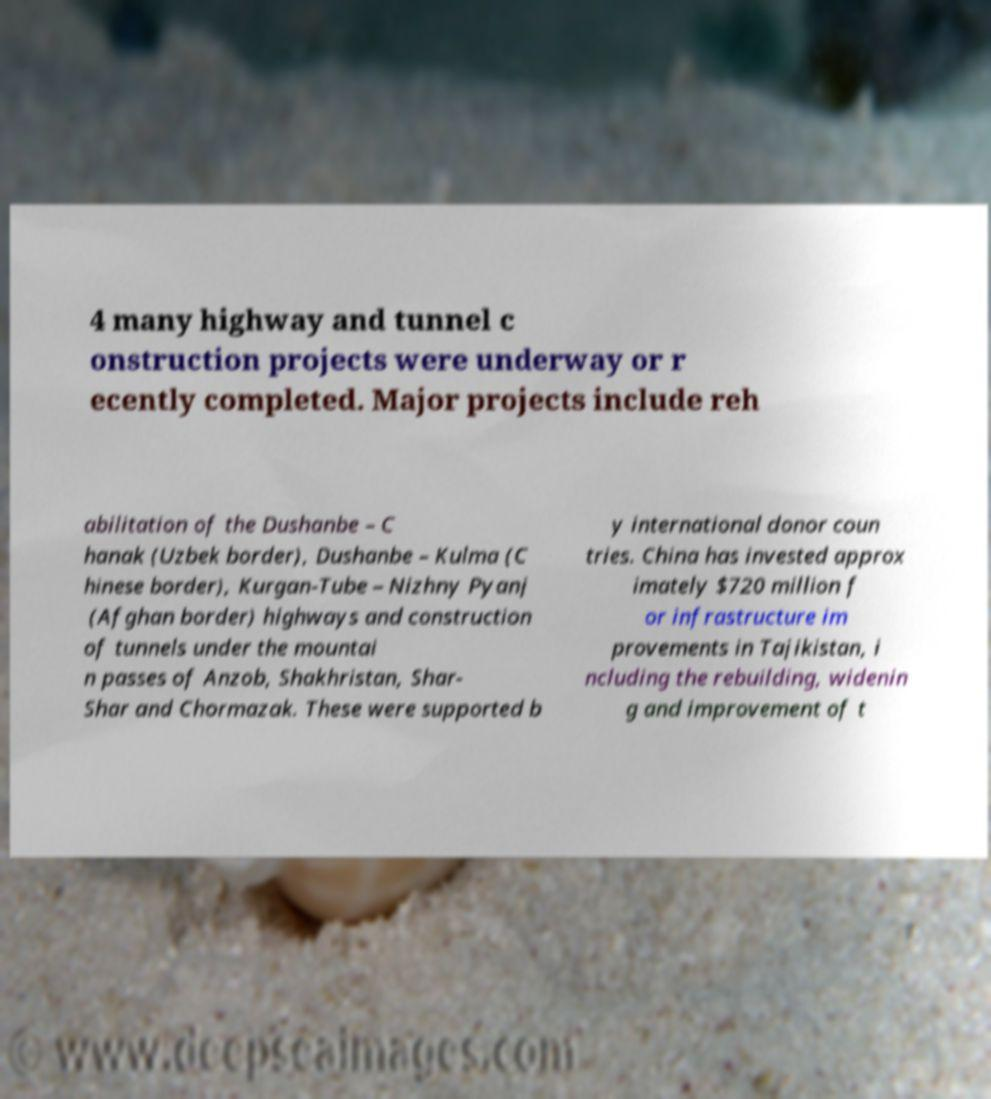For documentation purposes, I need the text within this image transcribed. Could you provide that? 4 many highway and tunnel c onstruction projects were underway or r ecently completed. Major projects include reh abilitation of the Dushanbe – C hanak (Uzbek border), Dushanbe – Kulma (C hinese border), Kurgan-Tube – Nizhny Pyanj (Afghan border) highways and construction of tunnels under the mountai n passes of Anzob, Shakhristan, Shar- Shar and Chormazak. These were supported b y international donor coun tries. China has invested approx imately $720 million f or infrastructure im provements in Tajikistan, i ncluding the rebuilding, widenin g and improvement of t 